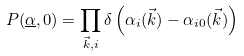<formula> <loc_0><loc_0><loc_500><loc_500>P ( \underline { \alpha } , 0 ) = \prod _ { \vec { k } , i } \delta \left ( \alpha _ { i } ( \vec { k } ) - \alpha _ { i 0 } ( \vec { k } ) \right )</formula> 